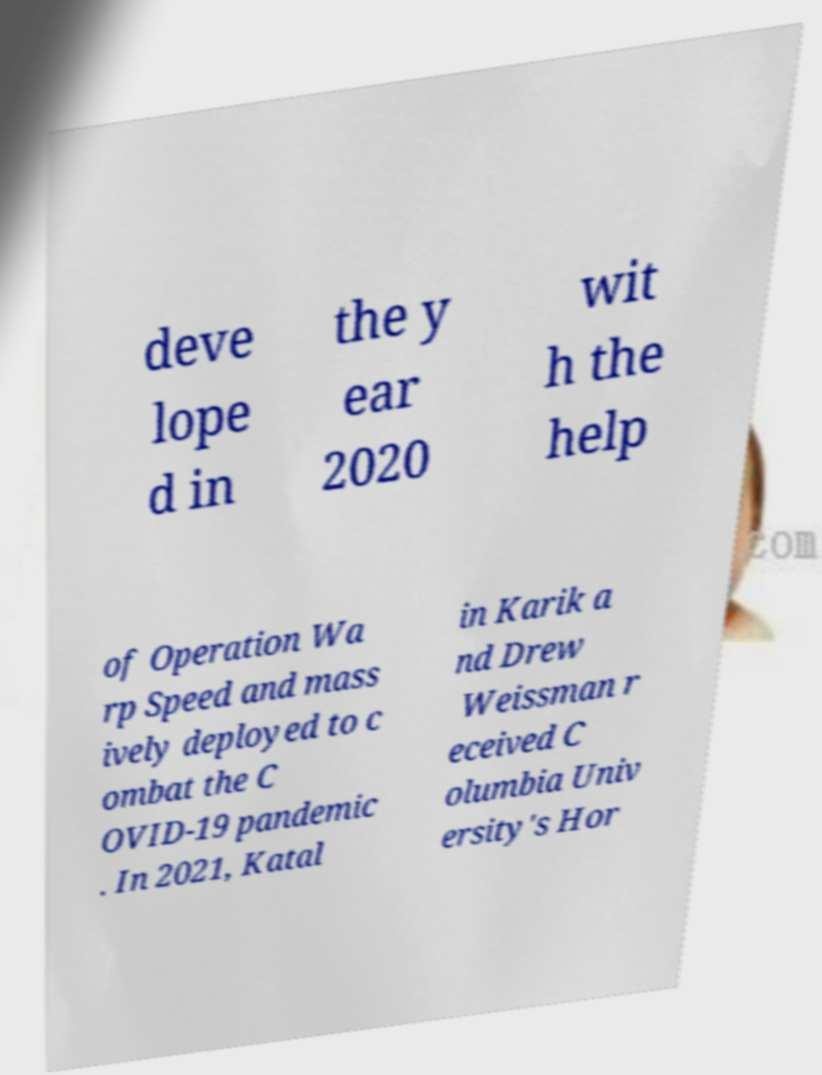What messages or text are displayed in this image? I need them in a readable, typed format. deve lope d in the y ear 2020 wit h the help of Operation Wa rp Speed and mass ively deployed to c ombat the C OVID-19 pandemic . In 2021, Katal in Karik a nd Drew Weissman r eceived C olumbia Univ ersity's Hor 